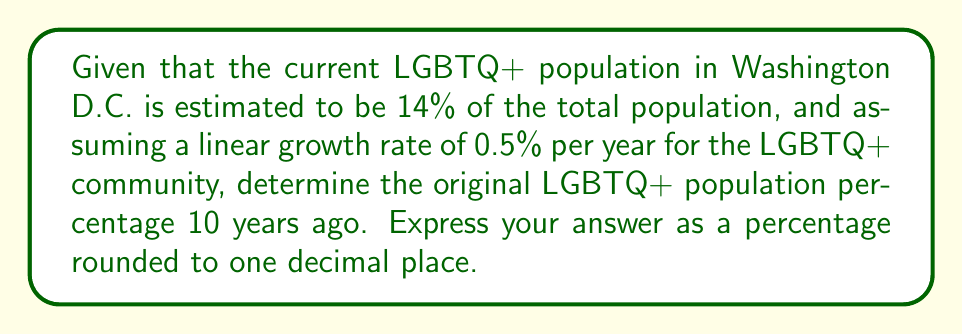Provide a solution to this math problem. Let's approach this step-by-step:

1) Let $x$ be the original LGBTQ+ population percentage 10 years ago.

2) We know that the population grows linearly by 0.5% each year. So after 10 years, the increase would be:

   $10 \times 0.5\% = 5\%$

3) We can express this as an equation:

   $x + 5\% = 14\%$

4) To solve for $x$, we subtract 5% from both sides:

   $x = 14\% - 5\% = 9\%$

5) Therefore, the original LGBTQ+ population percentage 10 years ago was 9%.

This problem demonstrates an inverse problem in demographics, where we use current data to infer past conditions. It's relevant to LGBTQ+ rights advocacy as it helps understand the growth and visibility of the community over time.
Answer: 9.0% 